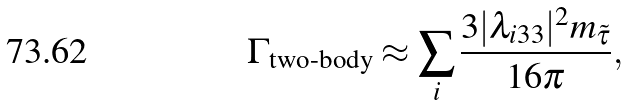Convert formula to latex. <formula><loc_0><loc_0><loc_500><loc_500>\Gamma _ { \text {two-body} } \approx \sum _ { i } \frac { 3 | \lambda _ { i 3 3 } | ^ { 2 } m _ { \tilde { \tau } } } { 1 6 \pi } ,</formula> 